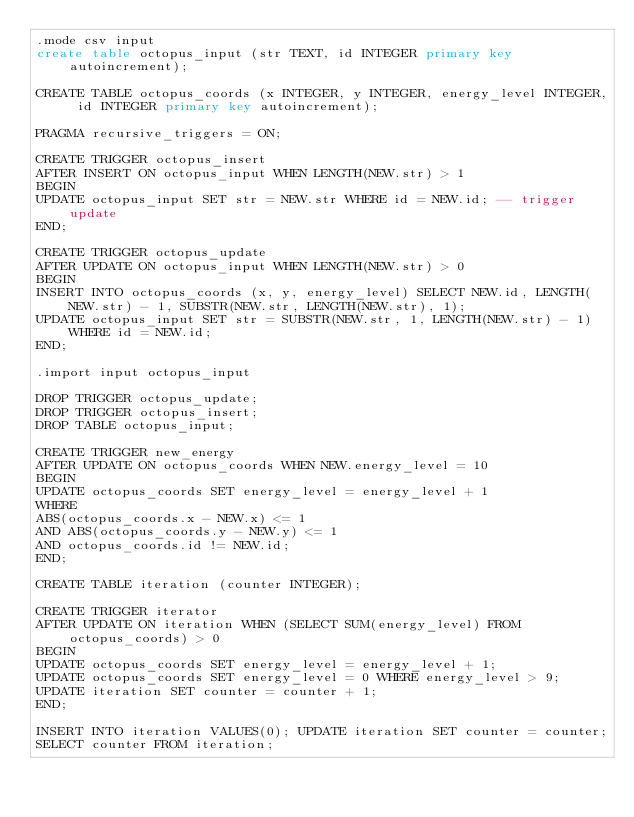Convert code to text. <code><loc_0><loc_0><loc_500><loc_500><_SQL_>.mode csv input
create table octopus_input (str TEXT, id INTEGER primary key autoincrement);

CREATE TABLE octopus_coords (x INTEGER, y INTEGER, energy_level INTEGER, id INTEGER primary key autoincrement);

PRAGMA recursive_triggers = ON;

CREATE TRIGGER octopus_insert
AFTER INSERT ON octopus_input WHEN LENGTH(NEW.str) > 1
BEGIN
UPDATE octopus_input SET str = NEW.str WHERE id = NEW.id; -- trigger update
END;

CREATE TRIGGER octopus_update
AFTER UPDATE ON octopus_input WHEN LENGTH(NEW.str) > 0
BEGIN
INSERT INTO octopus_coords (x, y, energy_level) SELECT NEW.id, LENGTH(NEW.str) - 1, SUBSTR(NEW.str, LENGTH(NEW.str), 1);
UPDATE octopus_input SET str = SUBSTR(NEW.str, 1, LENGTH(NEW.str) - 1) WHERE id = NEW.id;
END;

.import input octopus_input

DROP TRIGGER octopus_update;
DROP TRIGGER octopus_insert;
DROP TABLE octopus_input;

CREATE TRIGGER new_energy
AFTER UPDATE ON octopus_coords WHEN NEW.energy_level = 10
BEGIN
UPDATE octopus_coords SET energy_level = energy_level + 1
WHERE
ABS(octopus_coords.x - NEW.x) <= 1
AND ABS(octopus_coords.y - NEW.y) <= 1
AND octopus_coords.id != NEW.id;
END;

CREATE TABLE iteration (counter INTEGER);

CREATE TRIGGER iterator
AFTER UPDATE ON iteration WHEN (SELECT SUM(energy_level) FROM octopus_coords) > 0
BEGIN
UPDATE octopus_coords SET energy_level = energy_level + 1;
UPDATE octopus_coords SET energy_level = 0 WHERE energy_level > 9;
UPDATE iteration SET counter = counter + 1;
END;

INSERT INTO iteration VALUES(0); UPDATE iteration SET counter = counter;
SELECT counter FROM iteration;
</code> 